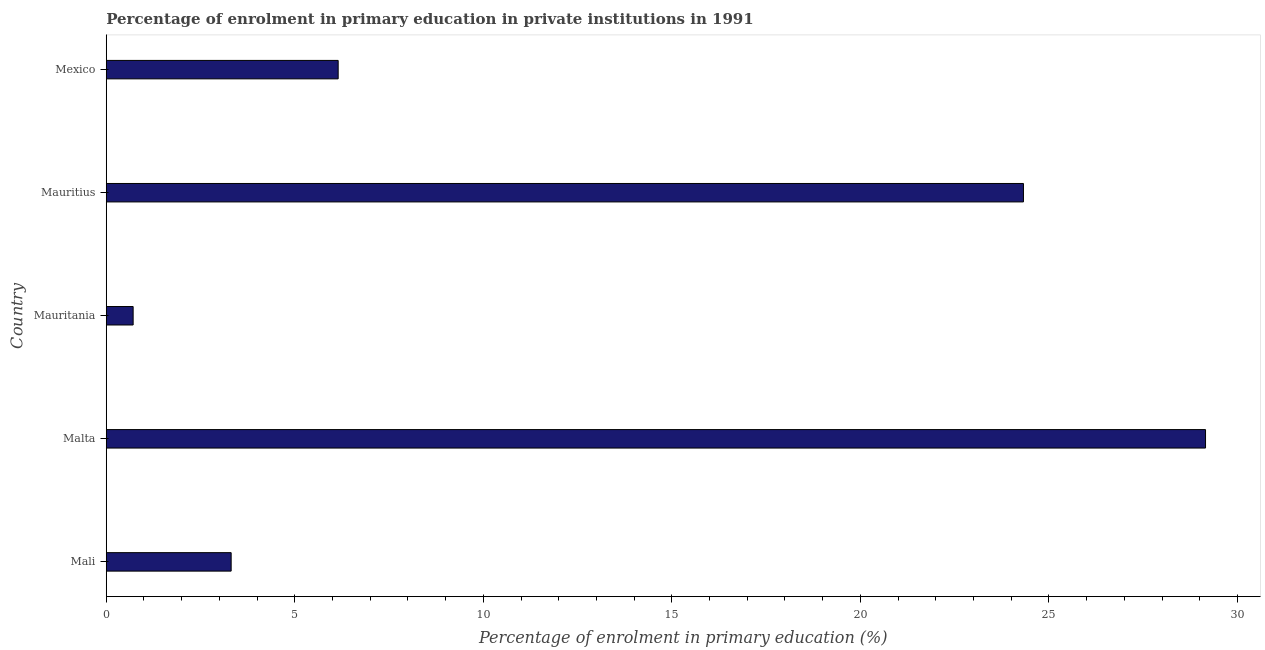Does the graph contain any zero values?
Keep it short and to the point. No. What is the title of the graph?
Your response must be concise. Percentage of enrolment in primary education in private institutions in 1991. What is the label or title of the X-axis?
Your response must be concise. Percentage of enrolment in primary education (%). What is the enrolment percentage in primary education in Mali?
Give a very brief answer. 3.31. Across all countries, what is the maximum enrolment percentage in primary education?
Your response must be concise. 29.15. Across all countries, what is the minimum enrolment percentage in primary education?
Provide a succinct answer. 0.71. In which country was the enrolment percentage in primary education maximum?
Keep it short and to the point. Malta. In which country was the enrolment percentage in primary education minimum?
Your response must be concise. Mauritania. What is the sum of the enrolment percentage in primary education?
Make the answer very short. 63.65. What is the difference between the enrolment percentage in primary education in Mauritania and Mauritius?
Give a very brief answer. -23.61. What is the average enrolment percentage in primary education per country?
Offer a very short reply. 12.73. What is the median enrolment percentage in primary education?
Ensure brevity in your answer.  6.15. In how many countries, is the enrolment percentage in primary education greater than 28 %?
Offer a terse response. 1. What is the ratio of the enrolment percentage in primary education in Mali to that in Mexico?
Offer a terse response. 0.54. What is the difference between the highest and the second highest enrolment percentage in primary education?
Provide a short and direct response. 4.83. What is the difference between the highest and the lowest enrolment percentage in primary education?
Your answer should be compact. 28.44. In how many countries, is the enrolment percentage in primary education greater than the average enrolment percentage in primary education taken over all countries?
Provide a succinct answer. 2. How many bars are there?
Provide a succinct answer. 5. How many countries are there in the graph?
Provide a short and direct response. 5. What is the difference between two consecutive major ticks on the X-axis?
Your answer should be very brief. 5. What is the Percentage of enrolment in primary education (%) of Mali?
Make the answer very short. 3.31. What is the Percentage of enrolment in primary education (%) of Malta?
Your answer should be compact. 29.15. What is the Percentage of enrolment in primary education (%) of Mauritania?
Ensure brevity in your answer.  0.71. What is the Percentage of enrolment in primary education (%) in Mauritius?
Keep it short and to the point. 24.32. What is the Percentage of enrolment in primary education (%) in Mexico?
Offer a very short reply. 6.15. What is the difference between the Percentage of enrolment in primary education (%) in Mali and Malta?
Your answer should be very brief. -25.84. What is the difference between the Percentage of enrolment in primary education (%) in Mali and Mauritania?
Your response must be concise. 2.6. What is the difference between the Percentage of enrolment in primary education (%) in Mali and Mauritius?
Provide a succinct answer. -21.01. What is the difference between the Percentage of enrolment in primary education (%) in Mali and Mexico?
Your answer should be compact. -2.84. What is the difference between the Percentage of enrolment in primary education (%) in Malta and Mauritania?
Provide a short and direct response. 28.44. What is the difference between the Percentage of enrolment in primary education (%) in Malta and Mauritius?
Give a very brief answer. 4.83. What is the difference between the Percentage of enrolment in primary education (%) in Malta and Mexico?
Provide a succinct answer. 23. What is the difference between the Percentage of enrolment in primary education (%) in Mauritania and Mauritius?
Your answer should be compact. -23.61. What is the difference between the Percentage of enrolment in primary education (%) in Mauritania and Mexico?
Offer a very short reply. -5.44. What is the difference between the Percentage of enrolment in primary education (%) in Mauritius and Mexico?
Provide a short and direct response. 18.17. What is the ratio of the Percentage of enrolment in primary education (%) in Mali to that in Malta?
Your answer should be very brief. 0.11. What is the ratio of the Percentage of enrolment in primary education (%) in Mali to that in Mauritania?
Offer a terse response. 4.64. What is the ratio of the Percentage of enrolment in primary education (%) in Mali to that in Mauritius?
Ensure brevity in your answer.  0.14. What is the ratio of the Percentage of enrolment in primary education (%) in Mali to that in Mexico?
Give a very brief answer. 0.54. What is the ratio of the Percentage of enrolment in primary education (%) in Malta to that in Mauritania?
Offer a terse response. 40.87. What is the ratio of the Percentage of enrolment in primary education (%) in Malta to that in Mauritius?
Give a very brief answer. 1.2. What is the ratio of the Percentage of enrolment in primary education (%) in Malta to that in Mexico?
Provide a succinct answer. 4.74. What is the ratio of the Percentage of enrolment in primary education (%) in Mauritania to that in Mauritius?
Keep it short and to the point. 0.03. What is the ratio of the Percentage of enrolment in primary education (%) in Mauritania to that in Mexico?
Offer a terse response. 0.12. What is the ratio of the Percentage of enrolment in primary education (%) in Mauritius to that in Mexico?
Offer a terse response. 3.96. 